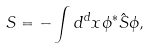<formula> <loc_0><loc_0><loc_500><loc_500>S = - \int d ^ { d } x \phi ^ { * } \hat { S } \phi ,</formula> 